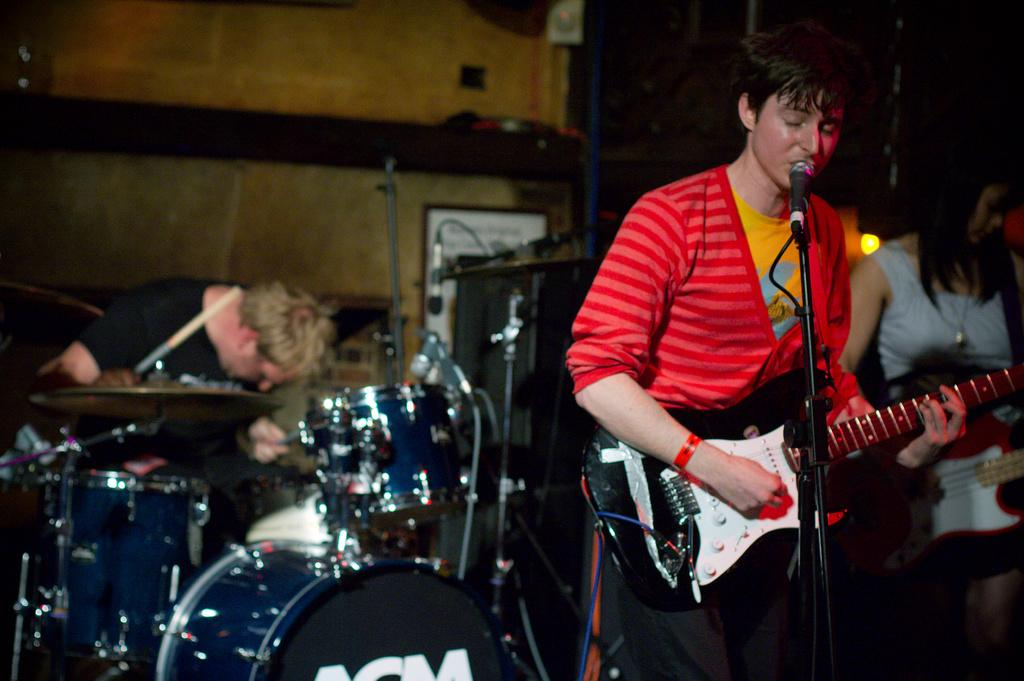What are the two people in the foreground of the image doing? There is a man standing and playing the guitar, and a woman standing and playing the guitar in the image. Can you describe the person in the background of the image? There is a person playing the drums in the background of the image. What type of brass instrument is being played during the feast in the image? There is no feast or brass instrument present in the image. 